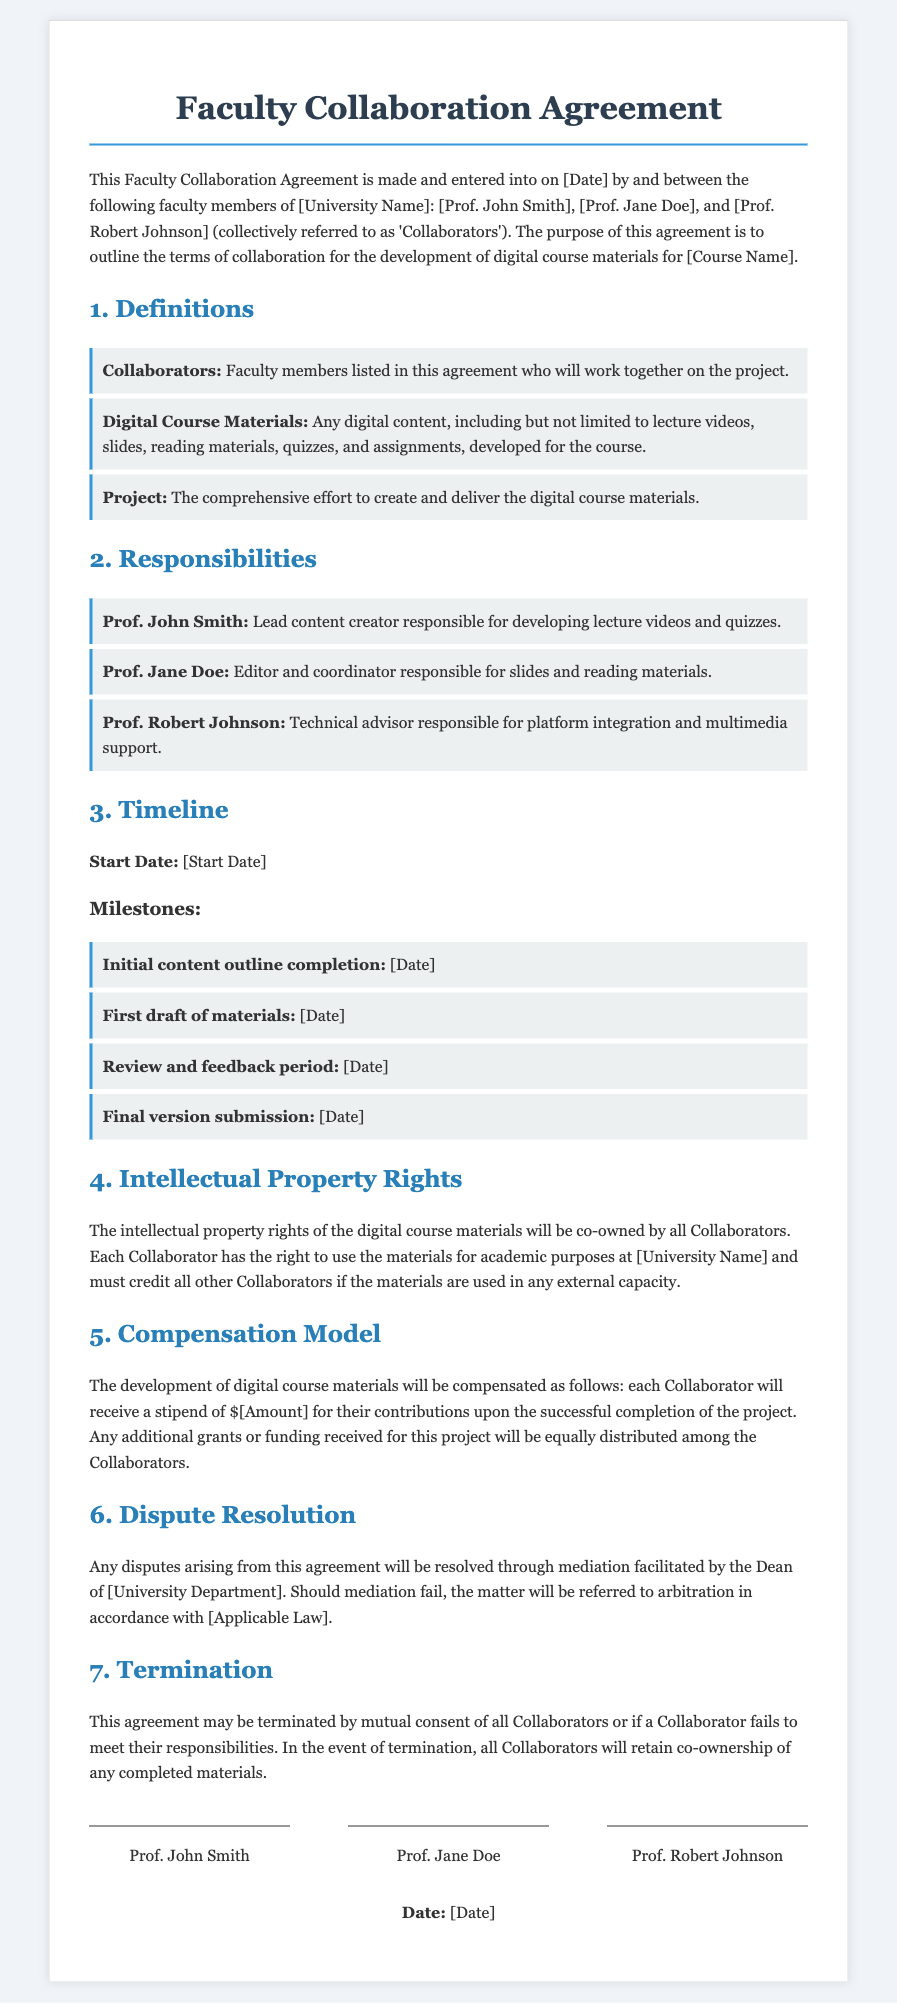What is the purpose of this agreement? The purpose of this agreement is to outline the terms of collaboration for the development of digital course materials for the course.
Answer: outline the terms of collaboration for the development of digital course materials Who is responsible for developing lecture videos and quizzes? Prof. John Smith is designated as the lead content creator responsible for these tasks.
Answer: Prof. John Smith What is the start date of the project? The start date is specified in the agreement but is currently marked as a placeholder.
Answer: [Start Date] How much stipend will each Collaborator receive? The compensation model indicates a stipend amount, which is currently set as a placeholder.
Answer: $[Amount] What happens if mediation fails? If mediation fails, the matter will be referred to arbitration.
Answer: referred to arbitration Who retains co-ownership of any completed materials in the event of termination? All Collaborators will retain co-ownership.
Answer: All Collaborators What type of materials are considered as Digital Course Materials? Digital Course Materials include any digital content developed for the course, such as lectures and quizzes.
Answer: Any digital content How is the compensation for additional grants distributed? Any additional grants received for the project will be equally distributed among the Collaborators.
Answer: equally distributed among the Collaborators What is the role of Prof. Jane Doe? Prof. Jane Doe is responsible for editing and coordinating slides and reading materials.
Answer: Editor and coordinator 